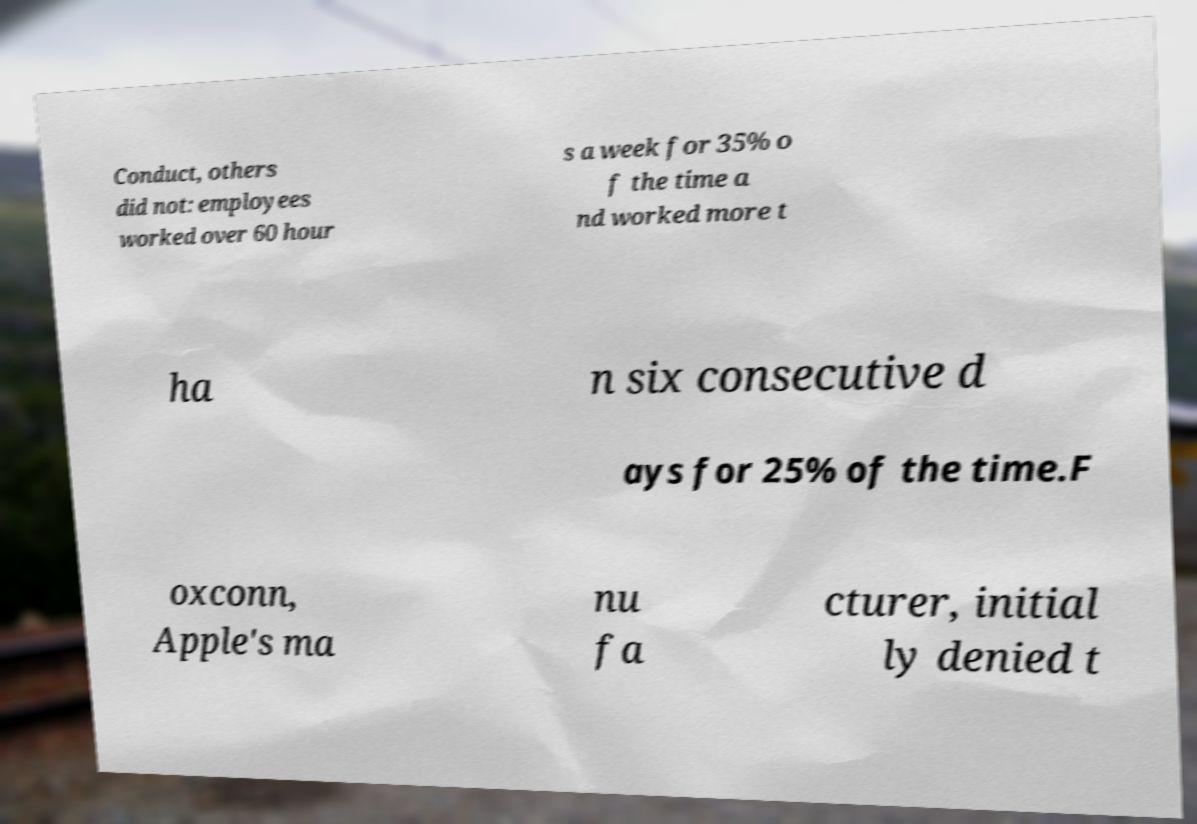Could you assist in decoding the text presented in this image and type it out clearly? Conduct, others did not: employees worked over 60 hour s a week for 35% o f the time a nd worked more t ha n six consecutive d ays for 25% of the time.F oxconn, Apple's ma nu fa cturer, initial ly denied t 